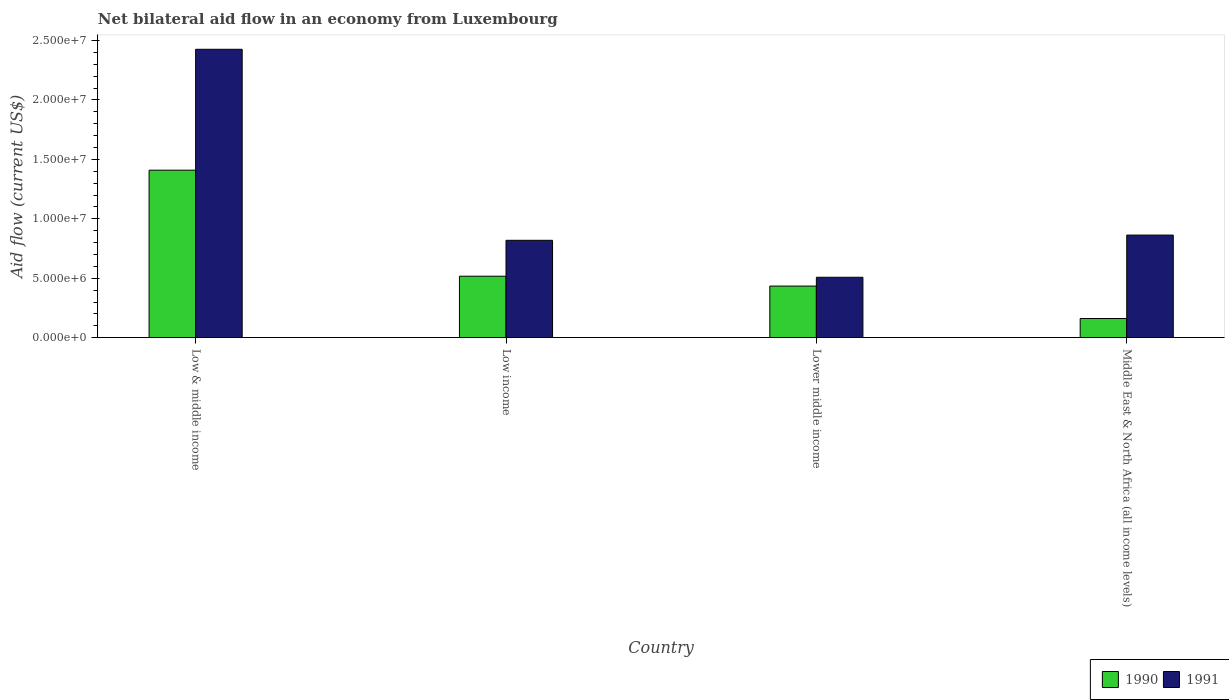How many groups of bars are there?
Give a very brief answer. 4. Are the number of bars on each tick of the X-axis equal?
Offer a terse response. Yes. How many bars are there on the 3rd tick from the left?
Make the answer very short. 2. What is the label of the 4th group of bars from the left?
Make the answer very short. Middle East & North Africa (all income levels). What is the net bilateral aid flow in 1990 in Middle East & North Africa (all income levels)?
Your answer should be compact. 1.61e+06. Across all countries, what is the maximum net bilateral aid flow in 1990?
Ensure brevity in your answer.  1.41e+07. Across all countries, what is the minimum net bilateral aid flow in 1990?
Offer a terse response. 1.61e+06. In which country was the net bilateral aid flow in 1991 maximum?
Your answer should be compact. Low & middle income. In which country was the net bilateral aid flow in 1991 minimum?
Your response must be concise. Lower middle income. What is the total net bilateral aid flow in 1990 in the graph?
Keep it short and to the point. 2.52e+07. What is the difference between the net bilateral aid flow in 1991 in Low & middle income and that in Low income?
Ensure brevity in your answer.  1.61e+07. What is the difference between the net bilateral aid flow in 1991 in Lower middle income and the net bilateral aid flow in 1990 in Low & middle income?
Offer a very short reply. -9.01e+06. What is the average net bilateral aid flow in 1990 per country?
Offer a very short reply. 6.30e+06. What is the difference between the net bilateral aid flow of/in 1991 and net bilateral aid flow of/in 1990 in Low income?
Offer a terse response. 3.02e+06. What is the ratio of the net bilateral aid flow in 1991 in Low & middle income to that in Low income?
Keep it short and to the point. 2.96. Is the net bilateral aid flow in 1991 in Low & middle income less than that in Lower middle income?
Provide a short and direct response. No. Is the difference between the net bilateral aid flow in 1991 in Low & middle income and Low income greater than the difference between the net bilateral aid flow in 1990 in Low & middle income and Low income?
Provide a succinct answer. Yes. What is the difference between the highest and the second highest net bilateral aid flow in 1991?
Provide a short and direct response. 1.61e+07. What is the difference between the highest and the lowest net bilateral aid flow in 1990?
Offer a very short reply. 1.25e+07. Is the sum of the net bilateral aid flow in 1990 in Low income and Middle East & North Africa (all income levels) greater than the maximum net bilateral aid flow in 1991 across all countries?
Ensure brevity in your answer.  No. What is the difference between two consecutive major ticks on the Y-axis?
Ensure brevity in your answer.  5.00e+06. Does the graph contain any zero values?
Your answer should be very brief. No. Where does the legend appear in the graph?
Offer a terse response. Bottom right. How many legend labels are there?
Your answer should be compact. 2. What is the title of the graph?
Give a very brief answer. Net bilateral aid flow in an economy from Luxembourg. Does "1993" appear as one of the legend labels in the graph?
Give a very brief answer. No. What is the Aid flow (current US$) of 1990 in Low & middle income?
Give a very brief answer. 1.41e+07. What is the Aid flow (current US$) in 1991 in Low & middle income?
Keep it short and to the point. 2.43e+07. What is the Aid flow (current US$) in 1990 in Low income?
Keep it short and to the point. 5.17e+06. What is the Aid flow (current US$) of 1991 in Low income?
Provide a short and direct response. 8.19e+06. What is the Aid flow (current US$) of 1990 in Lower middle income?
Your answer should be very brief. 4.34e+06. What is the Aid flow (current US$) in 1991 in Lower middle income?
Your answer should be compact. 5.08e+06. What is the Aid flow (current US$) in 1990 in Middle East & North Africa (all income levels)?
Make the answer very short. 1.61e+06. What is the Aid flow (current US$) of 1991 in Middle East & North Africa (all income levels)?
Make the answer very short. 8.63e+06. Across all countries, what is the maximum Aid flow (current US$) in 1990?
Your answer should be very brief. 1.41e+07. Across all countries, what is the maximum Aid flow (current US$) of 1991?
Provide a succinct answer. 2.43e+07. Across all countries, what is the minimum Aid flow (current US$) in 1990?
Offer a terse response. 1.61e+06. Across all countries, what is the minimum Aid flow (current US$) in 1991?
Your answer should be very brief. 5.08e+06. What is the total Aid flow (current US$) in 1990 in the graph?
Provide a succinct answer. 2.52e+07. What is the total Aid flow (current US$) of 1991 in the graph?
Give a very brief answer. 4.62e+07. What is the difference between the Aid flow (current US$) in 1990 in Low & middle income and that in Low income?
Provide a succinct answer. 8.92e+06. What is the difference between the Aid flow (current US$) of 1991 in Low & middle income and that in Low income?
Keep it short and to the point. 1.61e+07. What is the difference between the Aid flow (current US$) of 1990 in Low & middle income and that in Lower middle income?
Make the answer very short. 9.75e+06. What is the difference between the Aid flow (current US$) in 1991 in Low & middle income and that in Lower middle income?
Make the answer very short. 1.92e+07. What is the difference between the Aid flow (current US$) of 1990 in Low & middle income and that in Middle East & North Africa (all income levels)?
Your answer should be compact. 1.25e+07. What is the difference between the Aid flow (current US$) of 1991 in Low & middle income and that in Middle East & North Africa (all income levels)?
Ensure brevity in your answer.  1.56e+07. What is the difference between the Aid flow (current US$) of 1990 in Low income and that in Lower middle income?
Offer a terse response. 8.30e+05. What is the difference between the Aid flow (current US$) in 1991 in Low income and that in Lower middle income?
Offer a terse response. 3.11e+06. What is the difference between the Aid flow (current US$) in 1990 in Low income and that in Middle East & North Africa (all income levels)?
Provide a short and direct response. 3.56e+06. What is the difference between the Aid flow (current US$) in 1991 in Low income and that in Middle East & North Africa (all income levels)?
Provide a short and direct response. -4.40e+05. What is the difference between the Aid flow (current US$) of 1990 in Lower middle income and that in Middle East & North Africa (all income levels)?
Ensure brevity in your answer.  2.73e+06. What is the difference between the Aid flow (current US$) in 1991 in Lower middle income and that in Middle East & North Africa (all income levels)?
Offer a terse response. -3.55e+06. What is the difference between the Aid flow (current US$) in 1990 in Low & middle income and the Aid flow (current US$) in 1991 in Low income?
Your response must be concise. 5.90e+06. What is the difference between the Aid flow (current US$) in 1990 in Low & middle income and the Aid flow (current US$) in 1991 in Lower middle income?
Your response must be concise. 9.01e+06. What is the difference between the Aid flow (current US$) in 1990 in Low & middle income and the Aid flow (current US$) in 1991 in Middle East & North Africa (all income levels)?
Your answer should be compact. 5.46e+06. What is the difference between the Aid flow (current US$) in 1990 in Low income and the Aid flow (current US$) in 1991 in Lower middle income?
Your response must be concise. 9.00e+04. What is the difference between the Aid flow (current US$) of 1990 in Low income and the Aid flow (current US$) of 1991 in Middle East & North Africa (all income levels)?
Keep it short and to the point. -3.46e+06. What is the difference between the Aid flow (current US$) in 1990 in Lower middle income and the Aid flow (current US$) in 1991 in Middle East & North Africa (all income levels)?
Ensure brevity in your answer.  -4.29e+06. What is the average Aid flow (current US$) of 1990 per country?
Offer a very short reply. 6.30e+06. What is the average Aid flow (current US$) in 1991 per country?
Provide a succinct answer. 1.15e+07. What is the difference between the Aid flow (current US$) of 1990 and Aid flow (current US$) of 1991 in Low & middle income?
Keep it short and to the point. -1.02e+07. What is the difference between the Aid flow (current US$) in 1990 and Aid flow (current US$) in 1991 in Low income?
Provide a short and direct response. -3.02e+06. What is the difference between the Aid flow (current US$) in 1990 and Aid flow (current US$) in 1991 in Lower middle income?
Provide a short and direct response. -7.40e+05. What is the difference between the Aid flow (current US$) in 1990 and Aid flow (current US$) in 1991 in Middle East & North Africa (all income levels)?
Keep it short and to the point. -7.02e+06. What is the ratio of the Aid flow (current US$) in 1990 in Low & middle income to that in Low income?
Keep it short and to the point. 2.73. What is the ratio of the Aid flow (current US$) of 1991 in Low & middle income to that in Low income?
Your response must be concise. 2.96. What is the ratio of the Aid flow (current US$) of 1990 in Low & middle income to that in Lower middle income?
Give a very brief answer. 3.25. What is the ratio of the Aid flow (current US$) of 1991 in Low & middle income to that in Lower middle income?
Ensure brevity in your answer.  4.78. What is the ratio of the Aid flow (current US$) in 1990 in Low & middle income to that in Middle East & North Africa (all income levels)?
Keep it short and to the point. 8.75. What is the ratio of the Aid flow (current US$) of 1991 in Low & middle income to that in Middle East & North Africa (all income levels)?
Offer a very short reply. 2.81. What is the ratio of the Aid flow (current US$) in 1990 in Low income to that in Lower middle income?
Offer a terse response. 1.19. What is the ratio of the Aid flow (current US$) of 1991 in Low income to that in Lower middle income?
Your response must be concise. 1.61. What is the ratio of the Aid flow (current US$) of 1990 in Low income to that in Middle East & North Africa (all income levels)?
Your response must be concise. 3.21. What is the ratio of the Aid flow (current US$) in 1991 in Low income to that in Middle East & North Africa (all income levels)?
Make the answer very short. 0.95. What is the ratio of the Aid flow (current US$) of 1990 in Lower middle income to that in Middle East & North Africa (all income levels)?
Provide a short and direct response. 2.7. What is the ratio of the Aid flow (current US$) of 1991 in Lower middle income to that in Middle East & North Africa (all income levels)?
Offer a very short reply. 0.59. What is the difference between the highest and the second highest Aid flow (current US$) in 1990?
Your response must be concise. 8.92e+06. What is the difference between the highest and the second highest Aid flow (current US$) in 1991?
Your answer should be compact. 1.56e+07. What is the difference between the highest and the lowest Aid flow (current US$) of 1990?
Offer a terse response. 1.25e+07. What is the difference between the highest and the lowest Aid flow (current US$) of 1991?
Keep it short and to the point. 1.92e+07. 